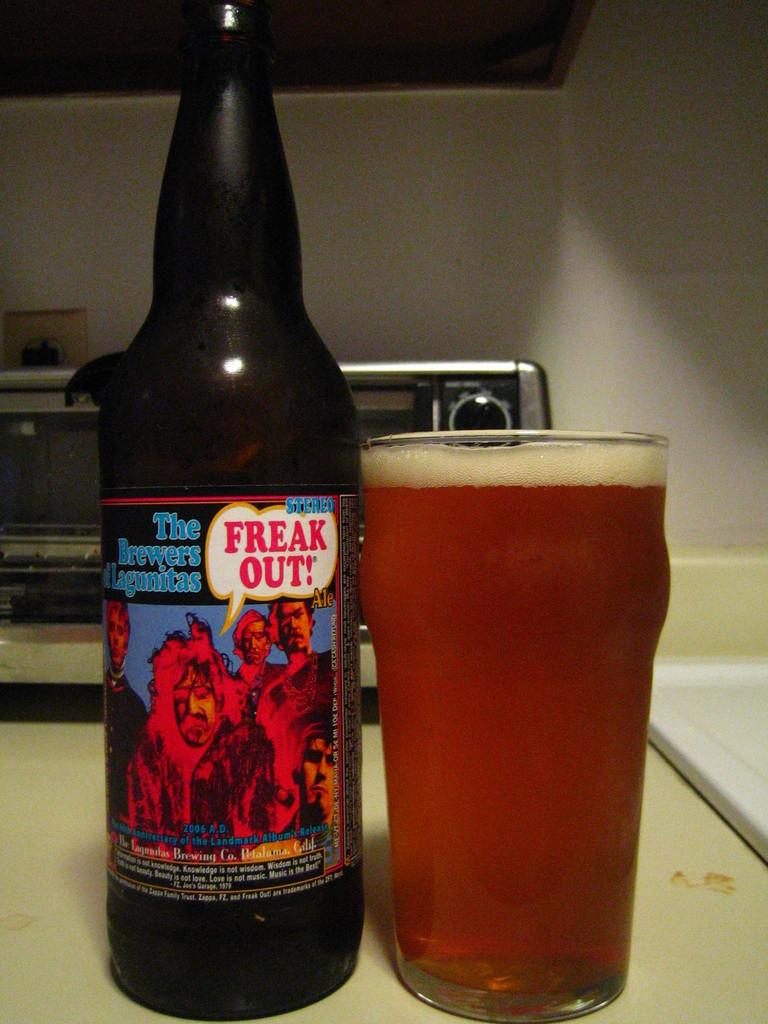<image>
Describe the image concisely. a glass and bottle of Freak Out on a large appliance 